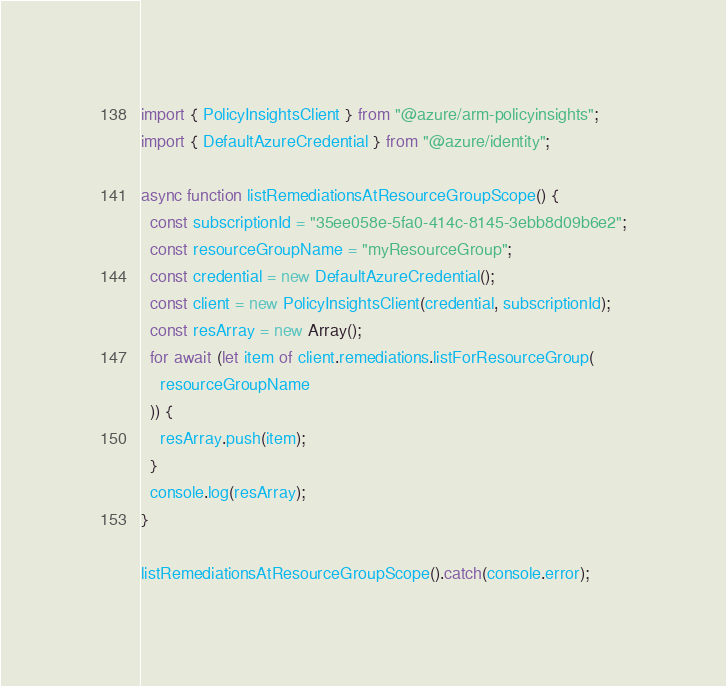Convert code to text. <code><loc_0><loc_0><loc_500><loc_500><_TypeScript_>import { PolicyInsightsClient } from "@azure/arm-policyinsights";
import { DefaultAzureCredential } from "@azure/identity";

async function listRemediationsAtResourceGroupScope() {
  const subscriptionId = "35ee058e-5fa0-414c-8145-3ebb8d09b6e2";
  const resourceGroupName = "myResourceGroup";
  const credential = new DefaultAzureCredential();
  const client = new PolicyInsightsClient(credential, subscriptionId);
  const resArray = new Array();
  for await (let item of client.remediations.listForResourceGroup(
    resourceGroupName
  )) {
    resArray.push(item);
  }
  console.log(resArray);
}

listRemediationsAtResourceGroupScope().catch(console.error);
</code> 